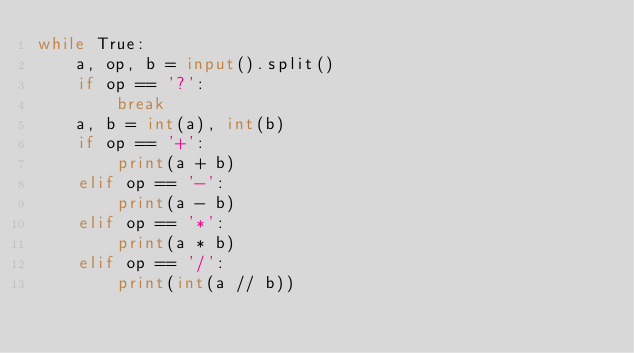<code> <loc_0><loc_0><loc_500><loc_500><_Python_>while True:
    a, op, b = input().split()
    if op == '?':
        break
    a, b = int(a), int(b)
    if op == '+':
        print(a + b)
    elif op == '-':
        print(a - b)
    elif op == '*':
        print(a * b)
    elif op == '/':
        print(int(a // b))
</code> 